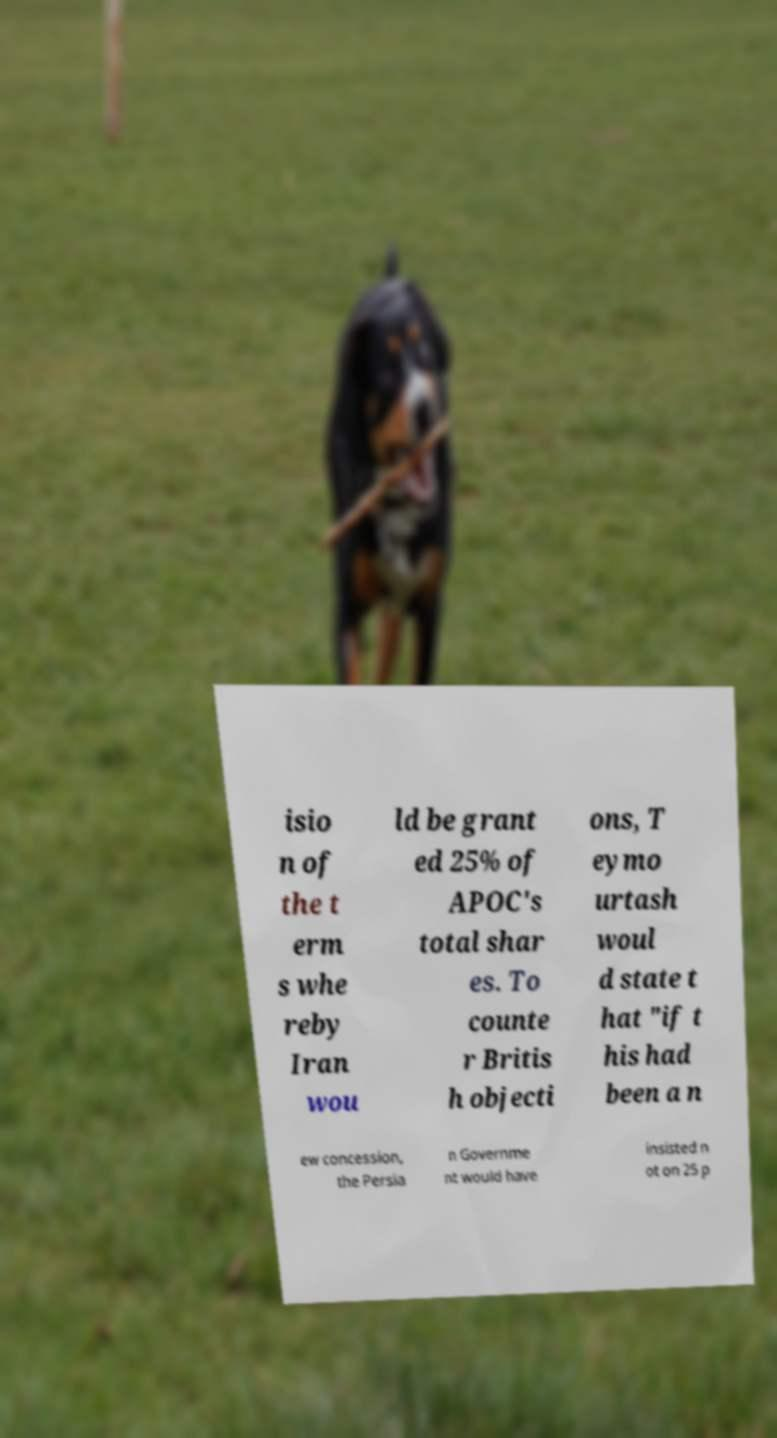Please identify and transcribe the text found in this image. isio n of the t erm s whe reby Iran wou ld be grant ed 25% of APOC's total shar es. To counte r Britis h objecti ons, T eymo urtash woul d state t hat "if t his had been a n ew concession, the Persia n Governme nt would have insisted n ot on 25 p 